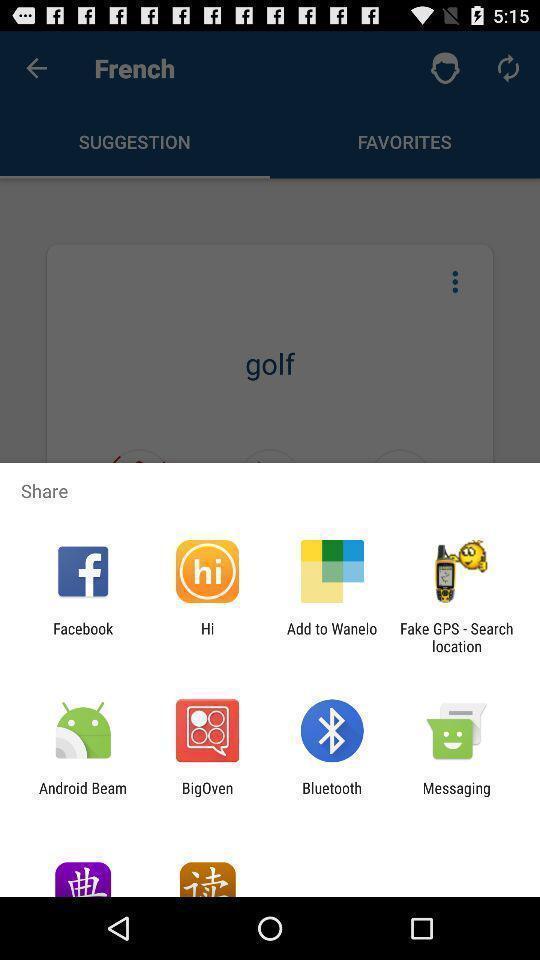Please provide a description for this image. Push up message for sharing data via social network. 